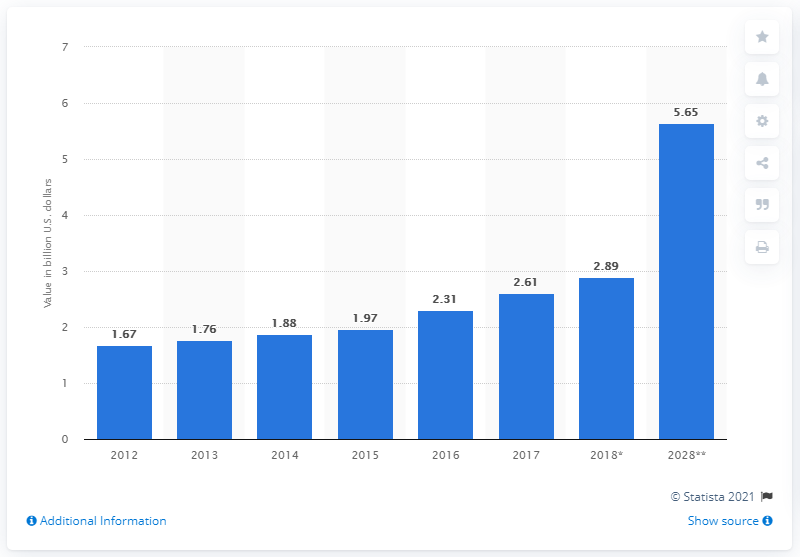Give some essential details in this illustration. In 2028, India's tourism spending was forecasted to reach a total of 5.65 billion US dollars. In 2017, India's tourism spending was 2.61 trillion rupees. 